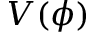Convert formula to latex. <formula><loc_0><loc_0><loc_500><loc_500>V ( \phi )</formula> 